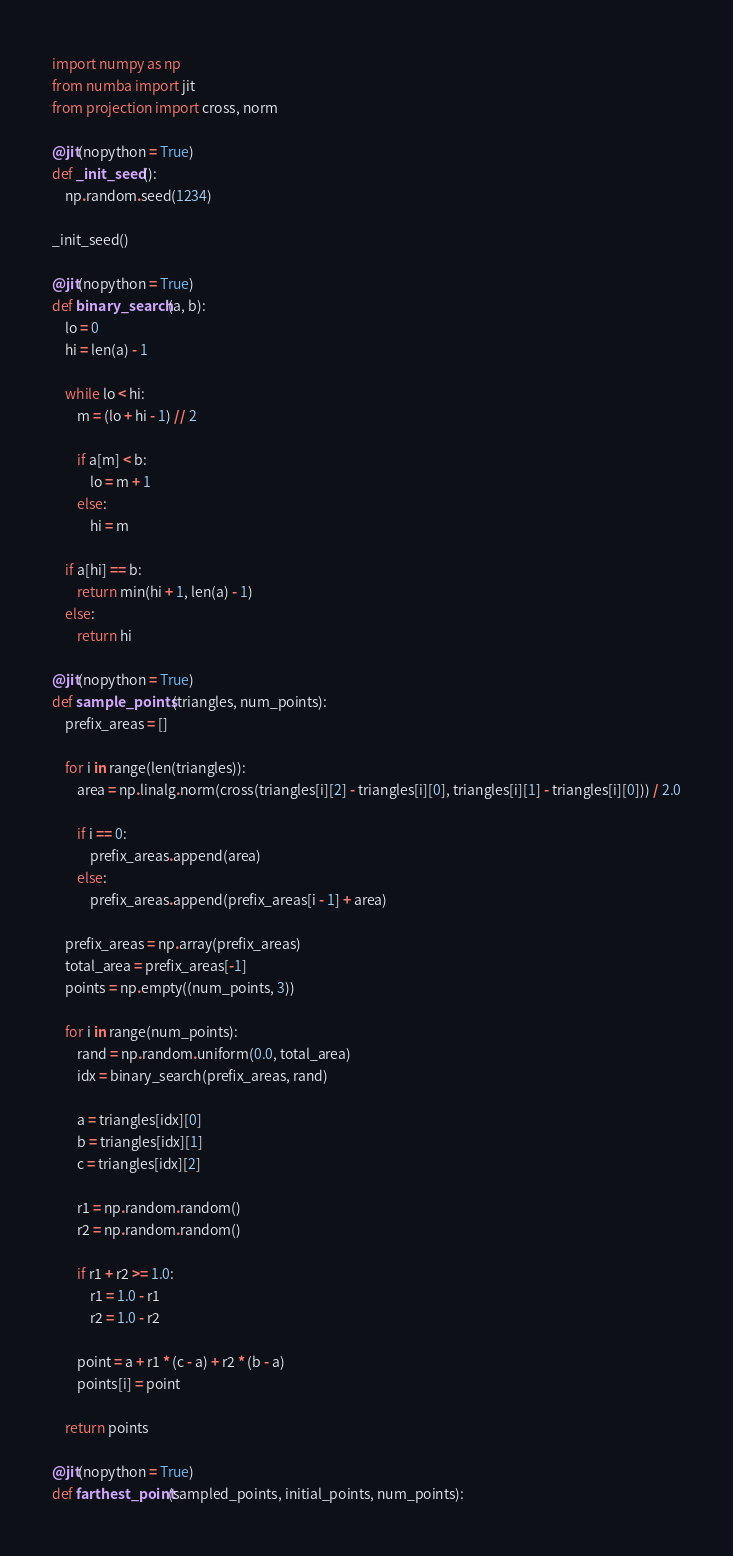Convert code to text. <code><loc_0><loc_0><loc_500><loc_500><_Python_>import numpy as np
from numba import jit
from projection import cross, norm

@jit(nopython = True)
def _init_seed():
    np.random.seed(1234)

_init_seed()

@jit(nopython = True)
def binary_search(a, b):
    lo = 0
    hi = len(a) - 1

    while lo < hi:
        m = (lo + hi - 1) // 2

        if a[m] < b:
            lo = m + 1
        else:
            hi = m

    if a[hi] == b:
        return min(hi + 1, len(a) - 1)
    else:
        return hi

@jit(nopython = True)
def sample_points(triangles, num_points):
    prefix_areas = []

    for i in range(len(triangles)):
        area = np.linalg.norm(cross(triangles[i][2] - triangles[i][0], triangles[i][1] - triangles[i][0])) / 2.0

        if i == 0:
            prefix_areas.append(area)
        else:
            prefix_areas.append(prefix_areas[i - 1] + area)

    prefix_areas = np.array(prefix_areas)
    total_area = prefix_areas[-1]
    points = np.empty((num_points, 3))

    for i in range(num_points):
        rand = np.random.uniform(0.0, total_area)
        idx = binary_search(prefix_areas, rand)

        a = triangles[idx][0]
        b = triangles[idx][1]
        c = triangles[idx][2]

        r1 = np.random.random()
        r2 = np.random.random()

        if r1 + r2 >= 1.0:
            r1 = 1.0 - r1
            r2 = 1.0 - r2

        point = a + r1 * (c - a) + r2 * (b - a)
        points[i] = point

    return points

@jit(nopython = True)
def farthest_point(sampled_points, initial_points, num_points):</code> 